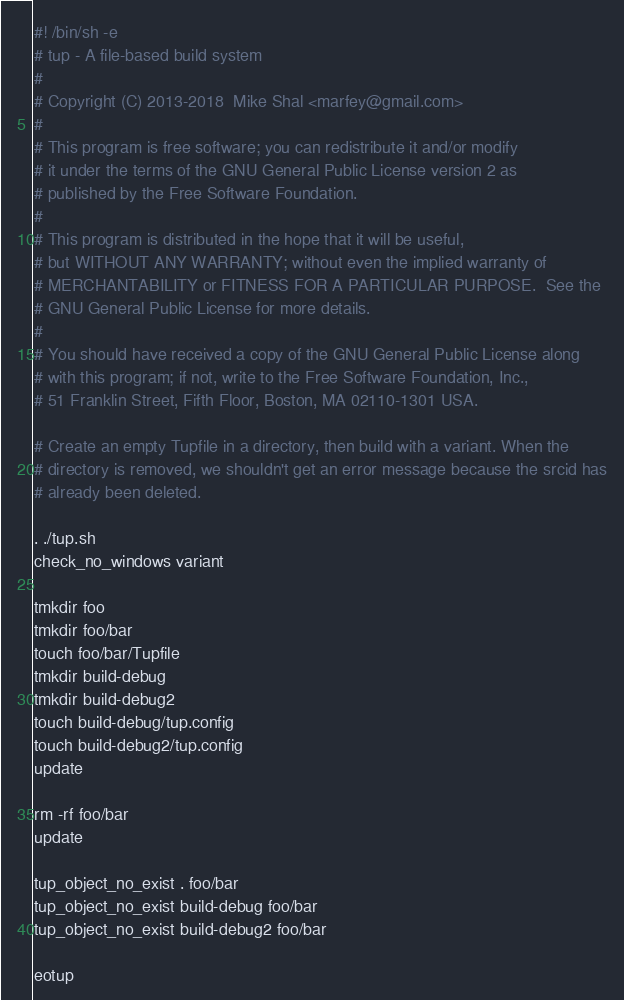Convert code to text. <code><loc_0><loc_0><loc_500><loc_500><_Bash_>#! /bin/sh -e
# tup - A file-based build system
#
# Copyright (C) 2013-2018  Mike Shal <marfey@gmail.com>
#
# This program is free software; you can redistribute it and/or modify
# it under the terms of the GNU General Public License version 2 as
# published by the Free Software Foundation.
#
# This program is distributed in the hope that it will be useful,
# but WITHOUT ANY WARRANTY; without even the implied warranty of
# MERCHANTABILITY or FITNESS FOR A PARTICULAR PURPOSE.  See the
# GNU General Public License for more details.
#
# You should have received a copy of the GNU General Public License along
# with this program; if not, write to the Free Software Foundation, Inc.,
# 51 Franklin Street, Fifth Floor, Boston, MA 02110-1301 USA.

# Create an empty Tupfile in a directory, then build with a variant. When the
# directory is removed, we shouldn't get an error message because the srcid has
# already been deleted.

. ./tup.sh
check_no_windows variant

tmkdir foo
tmkdir foo/bar
touch foo/bar/Tupfile
tmkdir build-debug
tmkdir build-debug2
touch build-debug/tup.config
touch build-debug2/tup.config
update

rm -rf foo/bar
update

tup_object_no_exist . foo/bar
tup_object_no_exist build-debug foo/bar
tup_object_no_exist build-debug2 foo/bar

eotup
</code> 